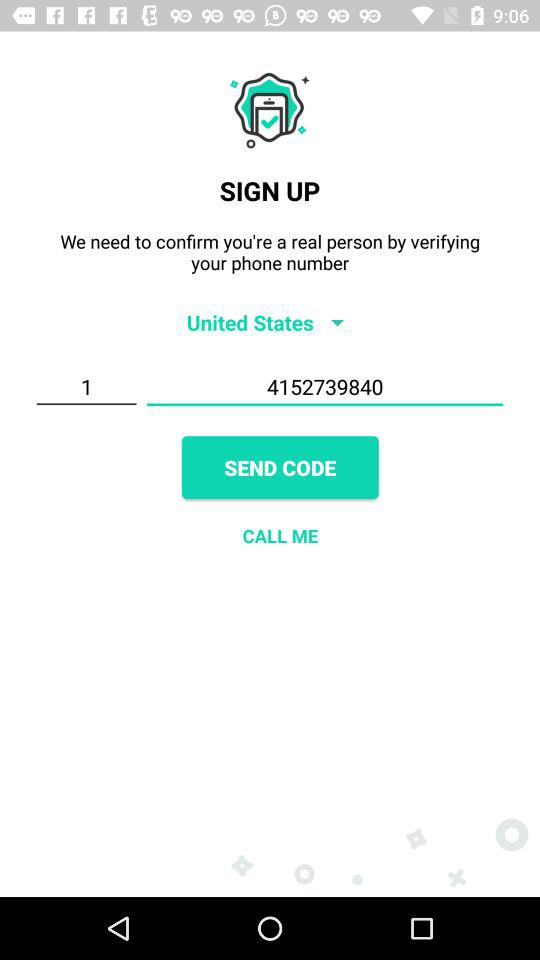What is the entered phone number? The entered phone number is +1 4152739840. 